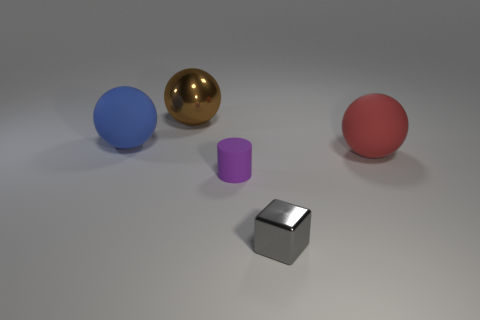Subtract 1 balls. How many balls are left? 2 Add 1 yellow blocks. How many objects exist? 6 Subtract all spheres. How many objects are left? 2 Add 5 purple spheres. How many purple spheres exist? 5 Subtract 0 yellow blocks. How many objects are left? 5 Subtract all tiny metallic objects. Subtract all gray matte things. How many objects are left? 4 Add 3 shiny cubes. How many shiny cubes are left? 4 